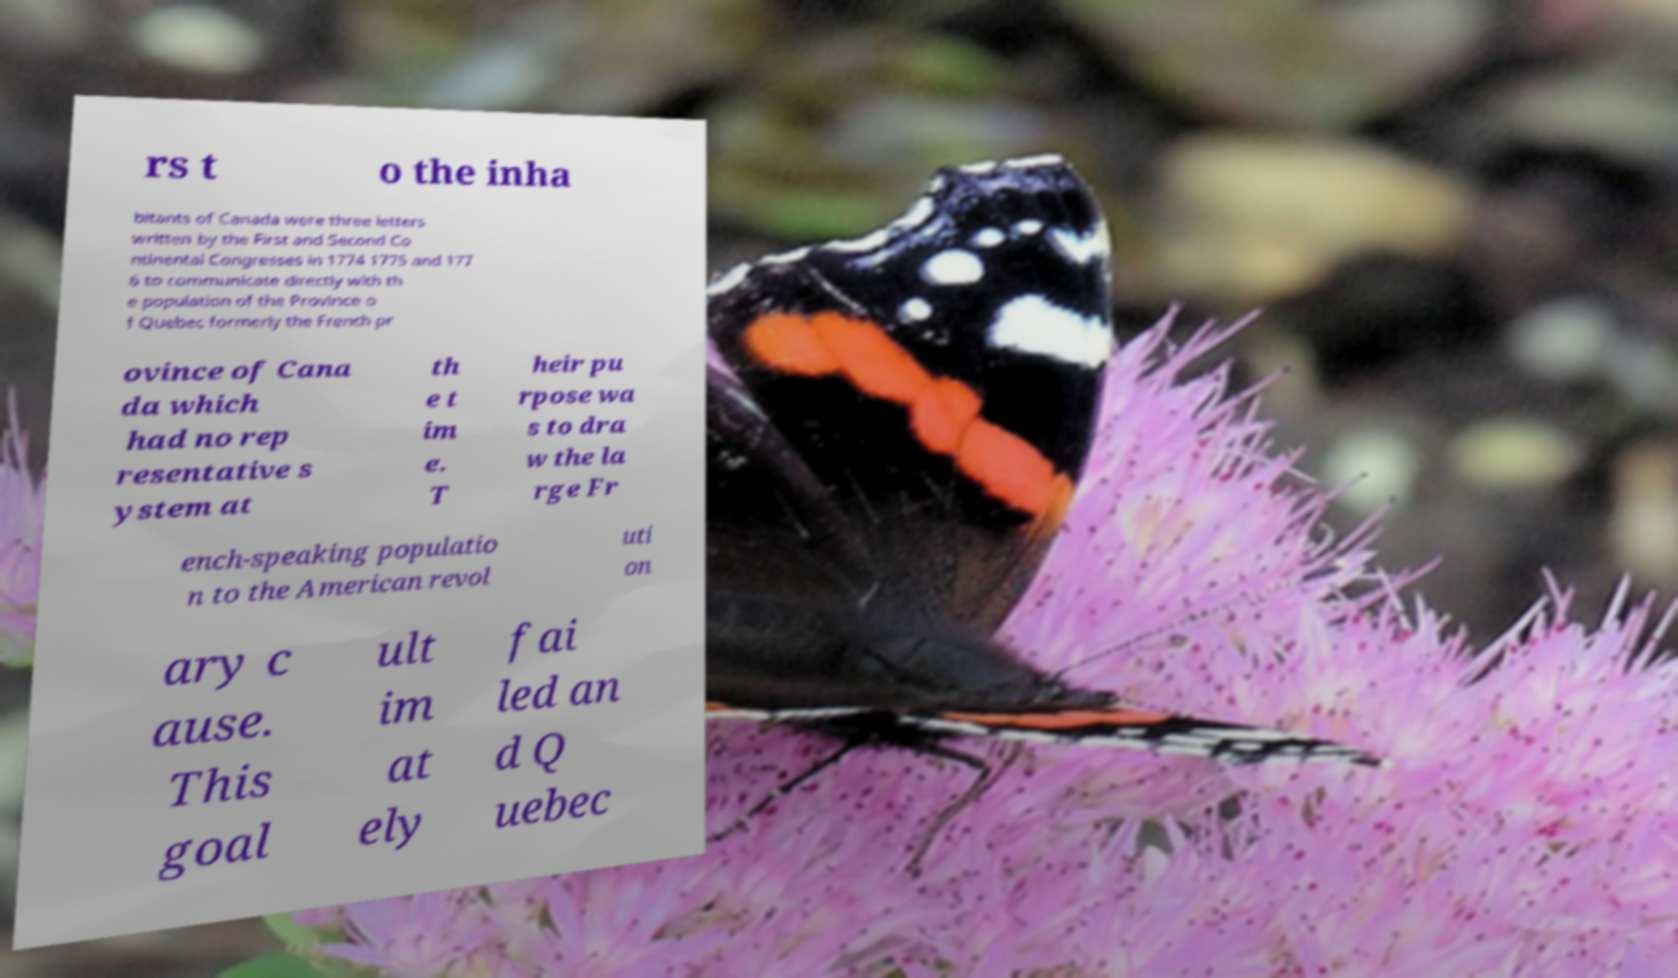Can you read and provide the text displayed in the image?This photo seems to have some interesting text. Can you extract and type it out for me? rs t o the inha bitants of Canada were three letters written by the First and Second Co ntinental Congresses in 1774 1775 and 177 6 to communicate directly with th e population of the Province o f Quebec formerly the French pr ovince of Cana da which had no rep resentative s ystem at th e t im e. T heir pu rpose wa s to dra w the la rge Fr ench-speaking populatio n to the American revol uti on ary c ause. This goal ult im at ely fai led an d Q uebec 